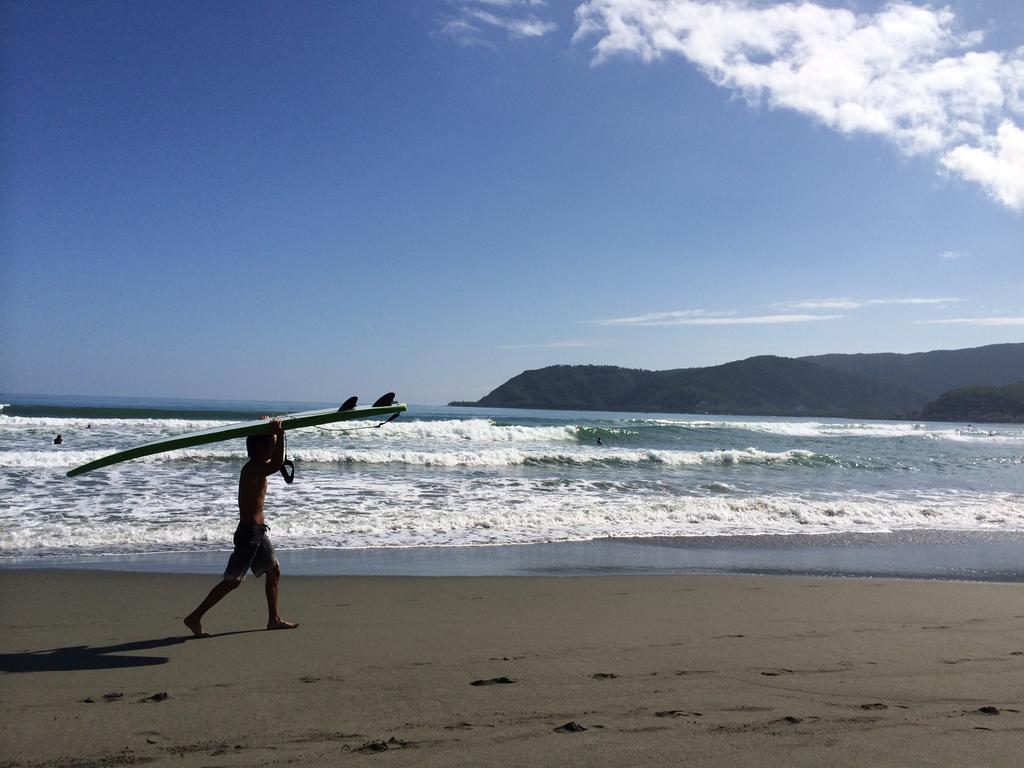Who is present in the image? There is a man in the image. What is the man holding in the image? The man is holding a ski-board. What type of terrain can be seen in the image? There is water and a mountain visible in the image. What is the price of the fire visible in the image? There is no fire present in the image, so it is not possible to determine its price. 